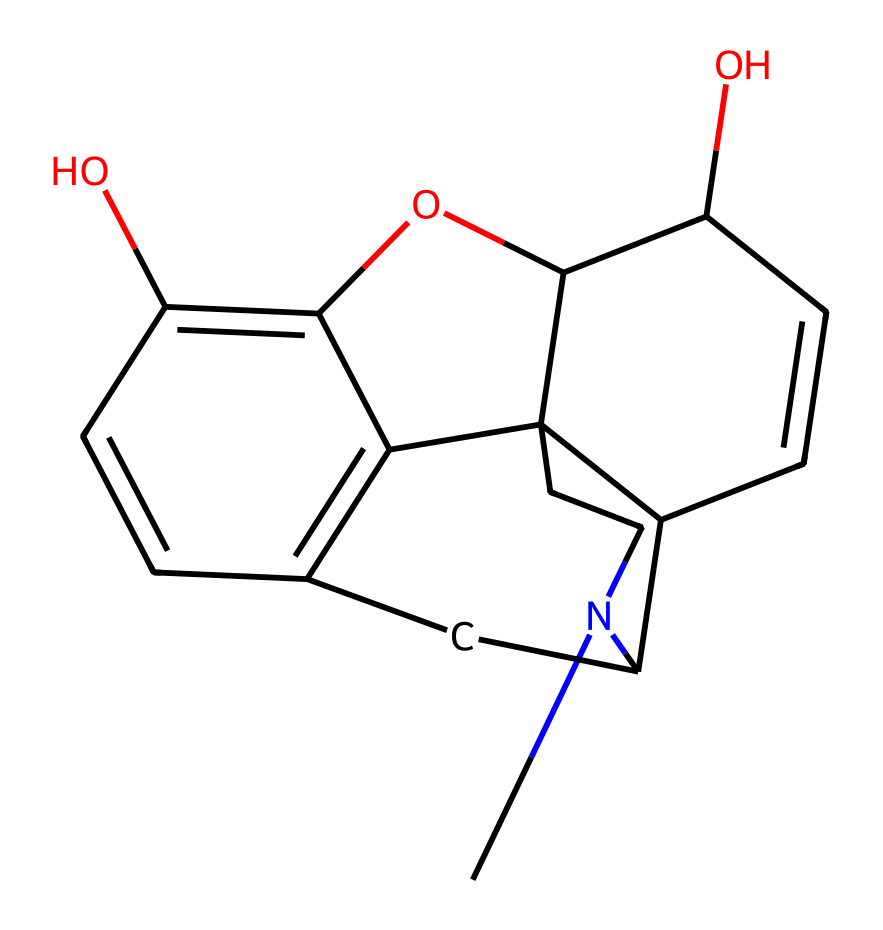What is the main functional group present in morphine? The structure of morphine contains multiple hydroxyl (OH) groups, which are indicative of alcohol functionalities. This is important for its solubility properties.
Answer: hydroxyl How many rings are present in the molecular structure of morphine? By analyzing the SMILES representation, we can count four distinct cyclic structures in the entire configuration. Rings affect the rigidity and overall shape of the molecule.
Answer: four What is the total number of carbon atoms in morphine? To determine the number of carbon atoms, we can parse the chemical representation, identifying each carbon (C) in the structure. There are 17 carbon atoms present.
Answer: seventeen Which element in morphine is responsible for its analgesic properties? Morphine exerts its pain-relieving effects through binding to opioid receptors, which primarily involve nitrogen atoms. This is a characteristic of many alkaloids.
Answer: nitrogen Is morphine classified as a natural or synthetic compound? Morphine is derived from the opium poppy and is used in medicinal contexts. Its source indicates that it is naturally occurring as opposed to being synthesized artificially.
Answer: natural What type of compound is morphine classified as? Morphine is a specific type of alkaloid, which is characterized by the presence of basic nitrogen atoms in a cyclic structure, contributing to its pharmacological activity.
Answer: alkaloid 